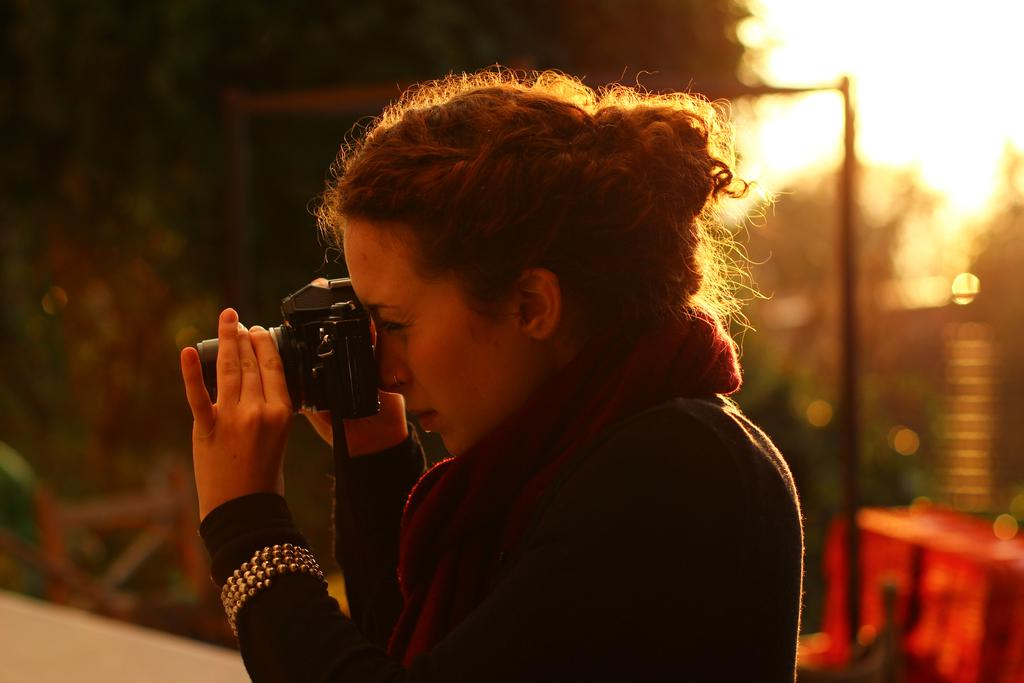What is the lady in the image doing? The lady is clicking a picture. What is the lady wearing in the image? The lady is wearing a black dress and a red scarf. What can be seen in the background of the image? There are trees in the background of the image. How many rings can be seen on the lady's fingers in the image? There is no mention of rings in the provided facts, so we cannot determine the number of rings on the lady's fingers. What type of spoon is the lady using to eat in the image? There is no spoon present in the image, as the lady is clicking a picture. 